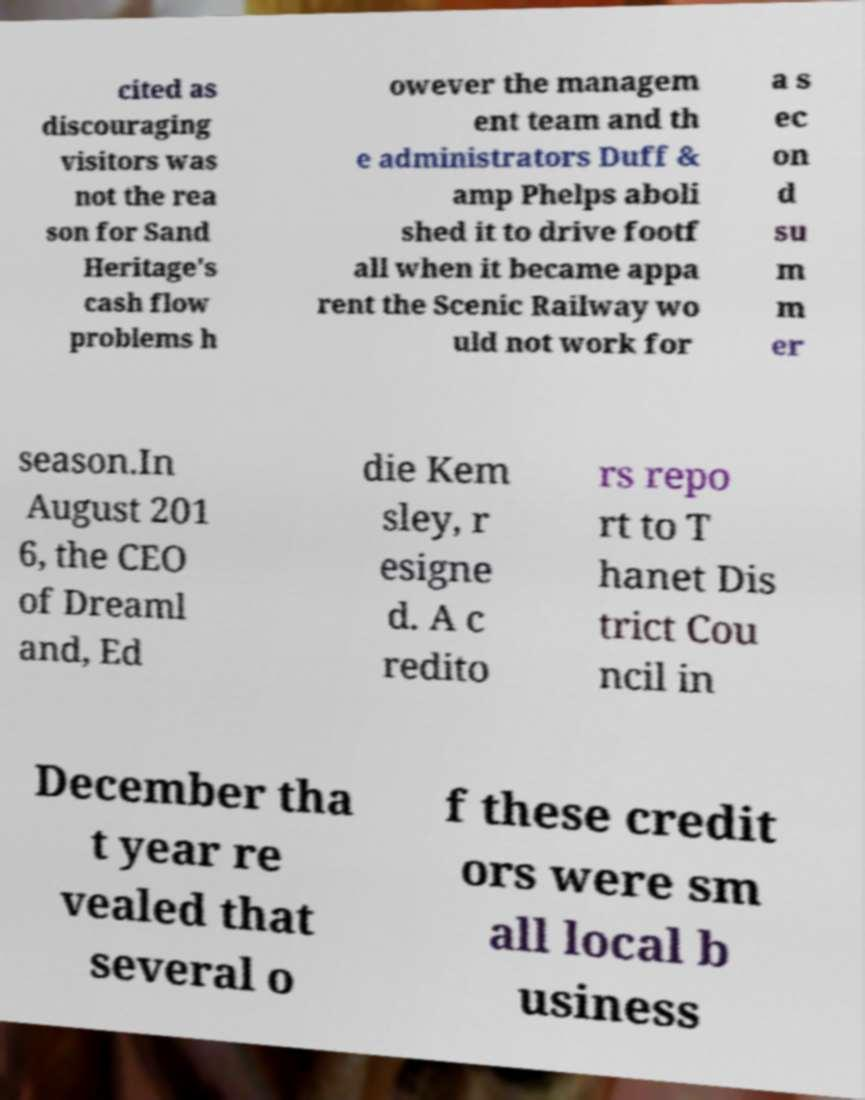Can you accurately transcribe the text from the provided image for me? cited as discouraging visitors was not the rea son for Sand Heritage's cash flow problems h owever the managem ent team and th e administrators Duff & amp Phelps aboli shed it to drive footf all when it became appa rent the Scenic Railway wo uld not work for a s ec on d su m m er season.In August 201 6, the CEO of Dreaml and, Ed die Kem sley, r esigne d. A c redito rs repo rt to T hanet Dis trict Cou ncil in December tha t year re vealed that several o f these credit ors were sm all local b usiness 